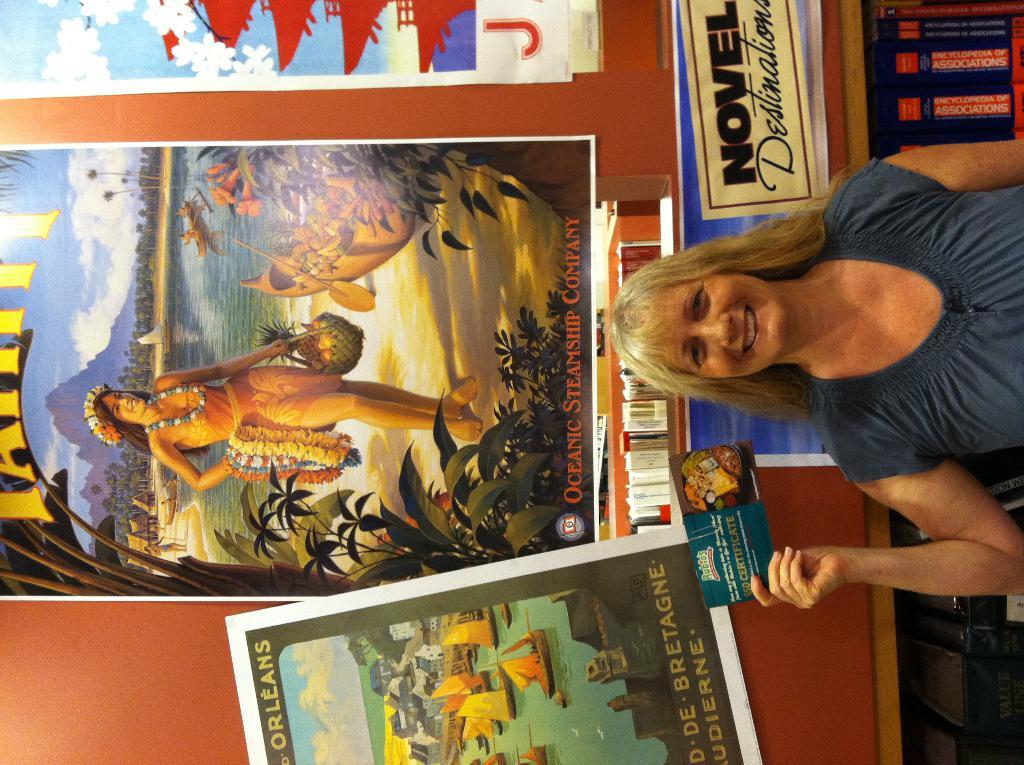<image>
Describe the image concisely. At the right of the blonde lady is the word novel. 